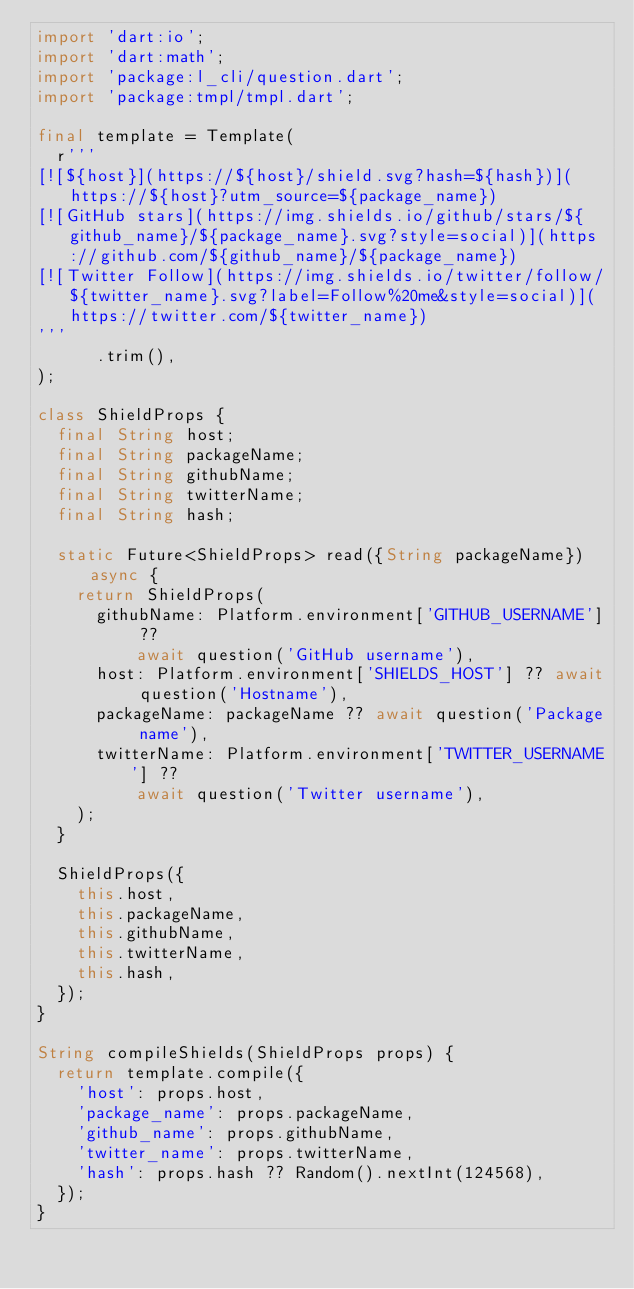<code> <loc_0><loc_0><loc_500><loc_500><_Dart_>import 'dart:io';
import 'dart:math';
import 'package:l_cli/question.dart';
import 'package:tmpl/tmpl.dart';

final template = Template(
  r'''
[![${host}](https://${host}/shield.svg?hash=${hash})](https://${host}?utm_source=${package_name})
[![GitHub stars](https://img.shields.io/github/stars/${github_name}/${package_name}.svg?style=social)](https://github.com/${github_name}/${package_name})
[![Twitter Follow](https://img.shields.io/twitter/follow/${twitter_name}.svg?label=Follow%20me&style=social)](https://twitter.com/${twitter_name})
'''
      .trim(),
);

class ShieldProps {
  final String host;
  final String packageName;
  final String githubName;
  final String twitterName;
  final String hash;

  static Future<ShieldProps> read({String packageName}) async {
    return ShieldProps(
      githubName: Platform.environment['GITHUB_USERNAME'] ??
          await question('GitHub username'),
      host: Platform.environment['SHIELDS_HOST'] ?? await question('Hostname'),
      packageName: packageName ?? await question('Package name'),
      twitterName: Platform.environment['TWITTER_USERNAME'] ??
          await question('Twitter username'),
    );
  }

  ShieldProps({
    this.host,
    this.packageName,
    this.githubName,
    this.twitterName,
    this.hash,
  });
}

String compileShields(ShieldProps props) {
  return template.compile({
    'host': props.host,
    'package_name': props.packageName,
    'github_name': props.githubName,
    'twitter_name': props.twitterName,
    'hash': props.hash ?? Random().nextInt(124568),
  });
}
</code> 